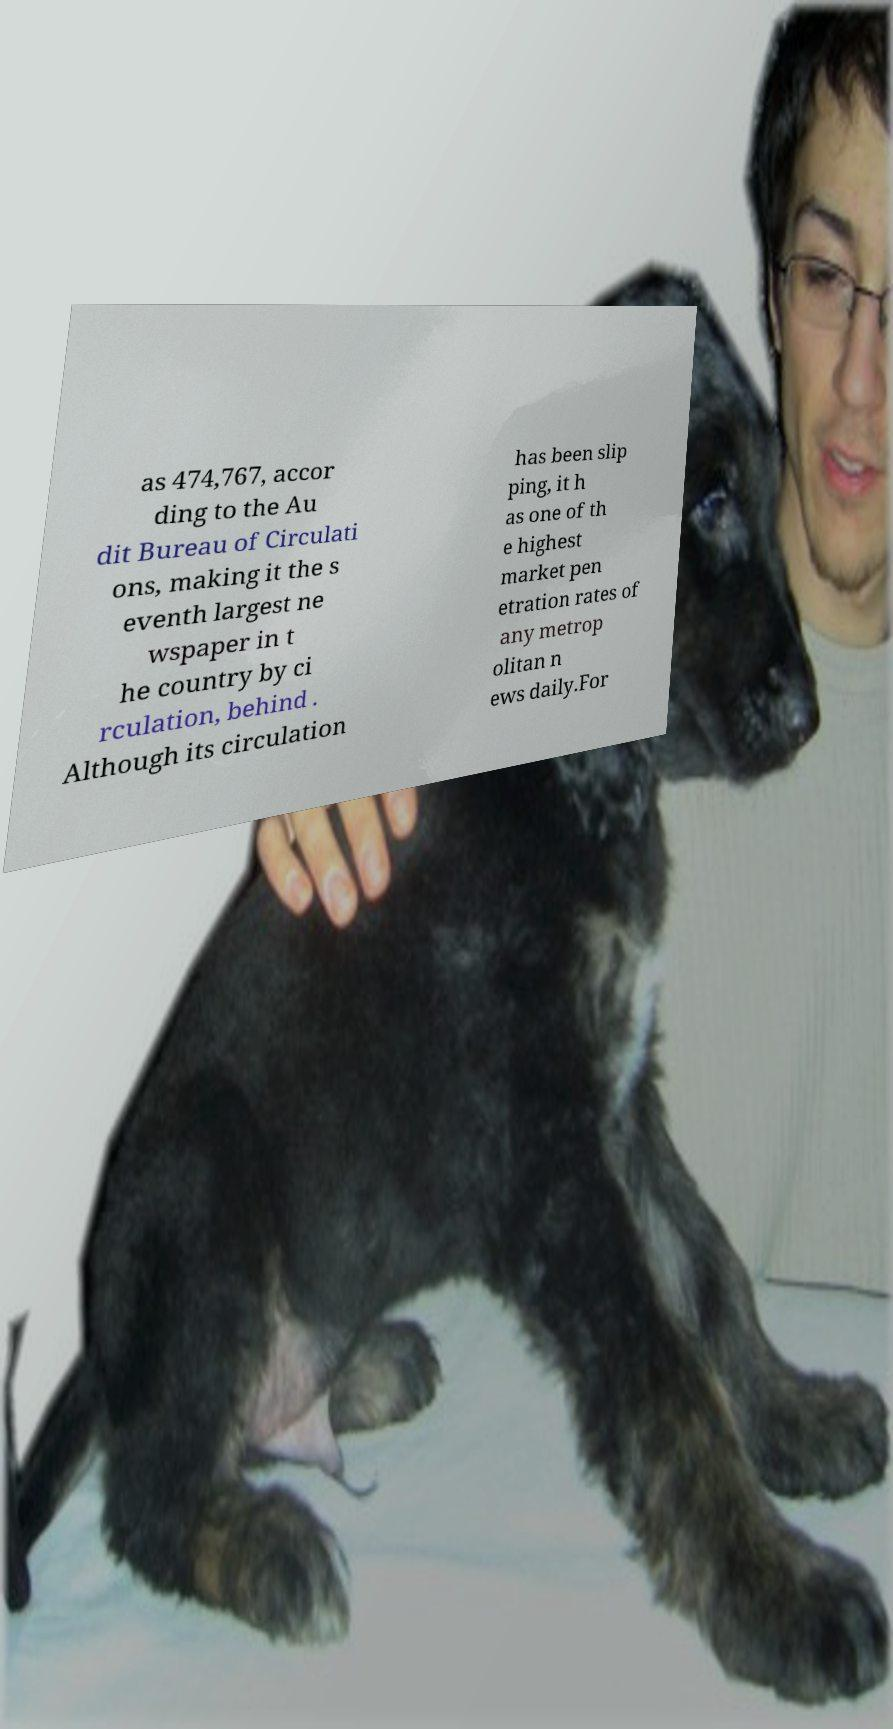Can you accurately transcribe the text from the provided image for me? as 474,767, accor ding to the Au dit Bureau of Circulati ons, making it the s eventh largest ne wspaper in t he country by ci rculation, behind . Although its circulation has been slip ping, it h as one of th e highest market pen etration rates of any metrop olitan n ews daily.For 